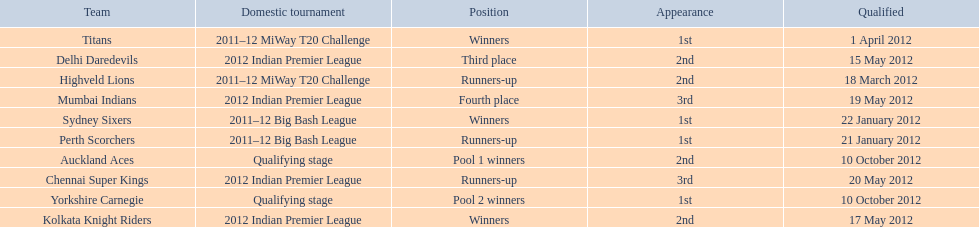What is the total number of teams? 10. 